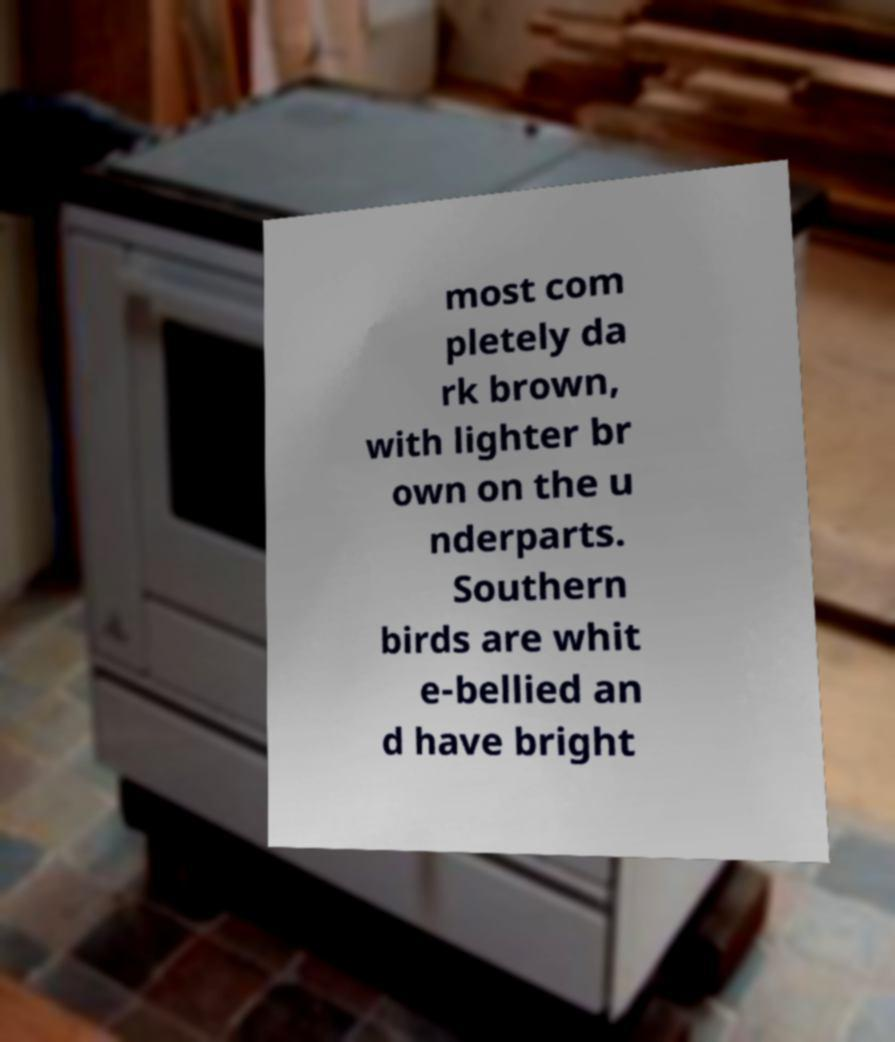What messages or text are displayed in this image? I need them in a readable, typed format. most com pletely da rk brown, with lighter br own on the u nderparts. Southern birds are whit e-bellied an d have bright 